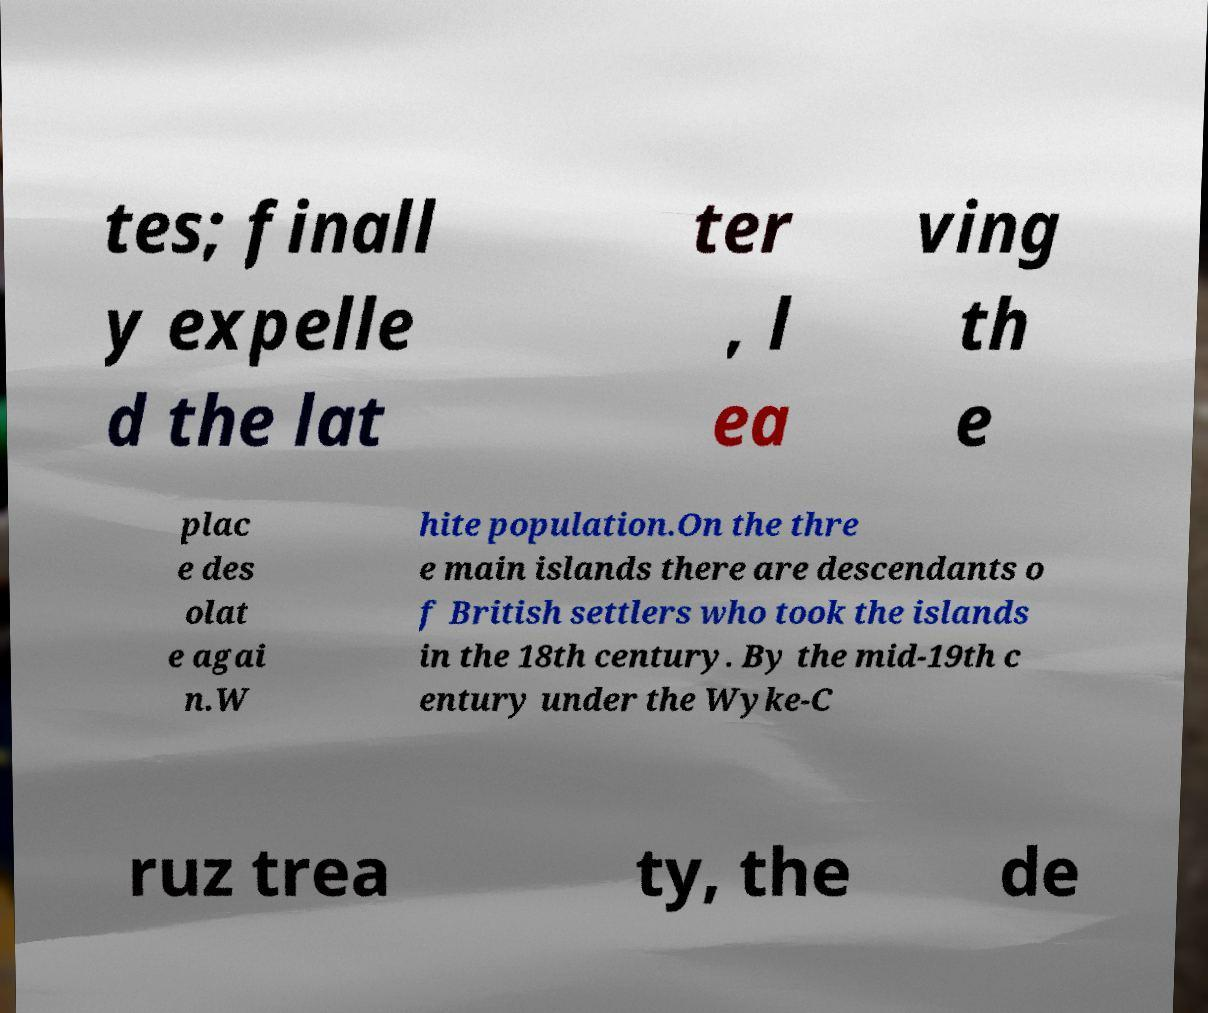I need the written content from this picture converted into text. Can you do that? tes; finall y expelle d the lat ter , l ea ving th e plac e des olat e agai n.W hite population.On the thre e main islands there are descendants o f British settlers who took the islands in the 18th century. By the mid-19th c entury under the Wyke-C ruz trea ty, the de 